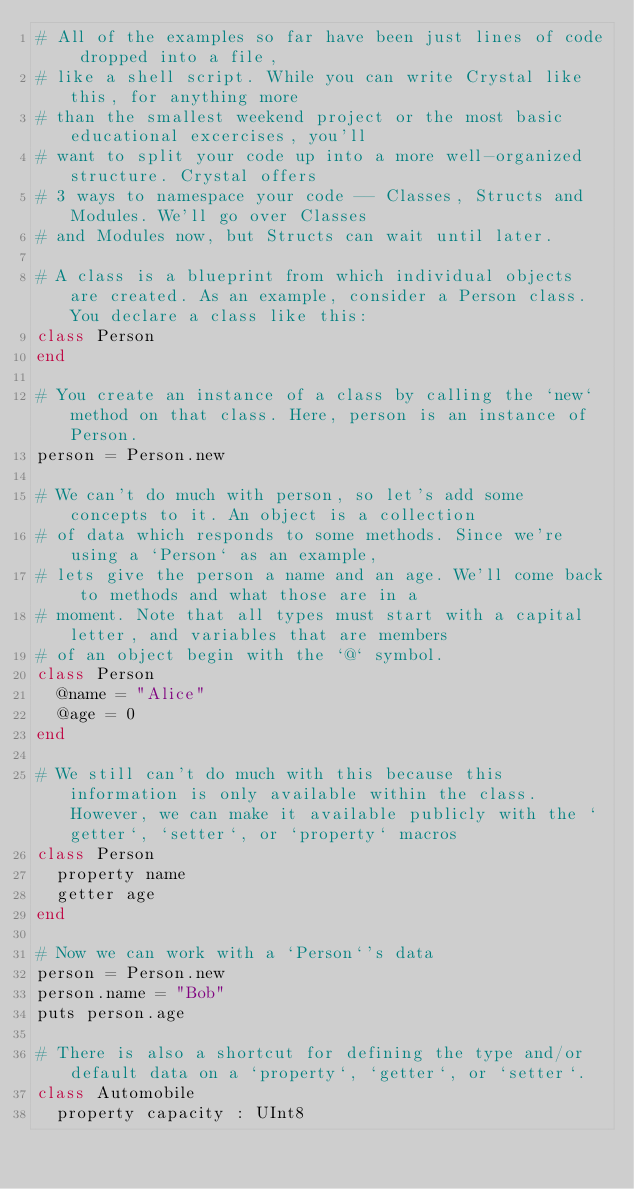<code> <loc_0><loc_0><loc_500><loc_500><_Crystal_># All of the examples so far have been just lines of code dropped into a file,
# like a shell script. While you can write Crystal like this, for anything more
# than the smallest weekend project or the most basic educational excercises, you'll
# want to split your code up into a more well-organized structure. Crystal offers
# 3 ways to namespace your code -- Classes, Structs and Modules. We'll go over Classes
# and Modules now, but Structs can wait until later.

# A class is a blueprint from which individual objects are created. As an example, consider a Person class. You declare a class like this:
class Person
end

# You create an instance of a class by calling the `new` method on that class. Here, person is an instance of Person.
person = Person.new

# We can't do much with person, so let's add some concepts to it. An object is a collection
# of data which responds to some methods. Since we're using a `Person` as an example,
# lets give the person a name and an age. We'll come back to methods and what those are in a
# moment. Note that all types must start with a capital letter, and variables that are members
# of an object begin with the `@` symbol.
class Person
  @name = "Alice"
  @age = 0
end

# We still can't do much with this because this information is only available within the class. However, we can make it available publicly with the `getter`, `setter`, or `property` macros
class Person
  property name
  getter age
end

# Now we can work with a `Person`'s data
person = Person.new
person.name = "Bob"
puts person.age

# There is also a shortcut for defining the type and/or default data on a `property`, `getter`, or `setter`.
class Automobile
  property capacity : UInt8</code> 